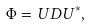Convert formula to latex. <formula><loc_0><loc_0><loc_500><loc_500>\Phi = U D U ^ { * } ,</formula> 